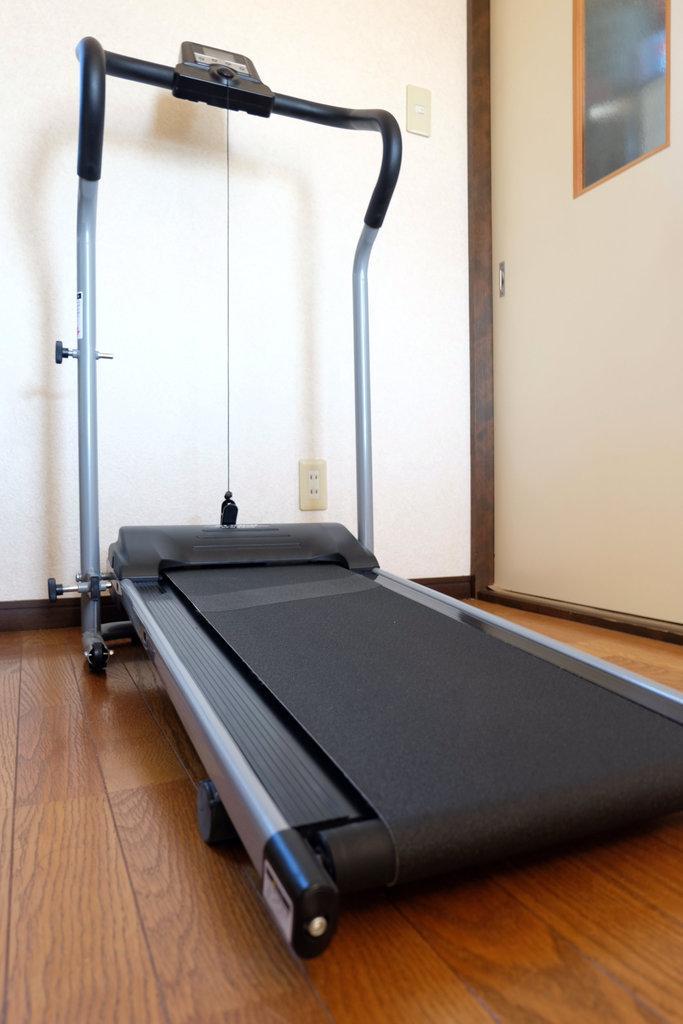Please provide a concise description of this image. In this image, I can see a treadmill on the wooden floor. In the background there is a wall and a door. 